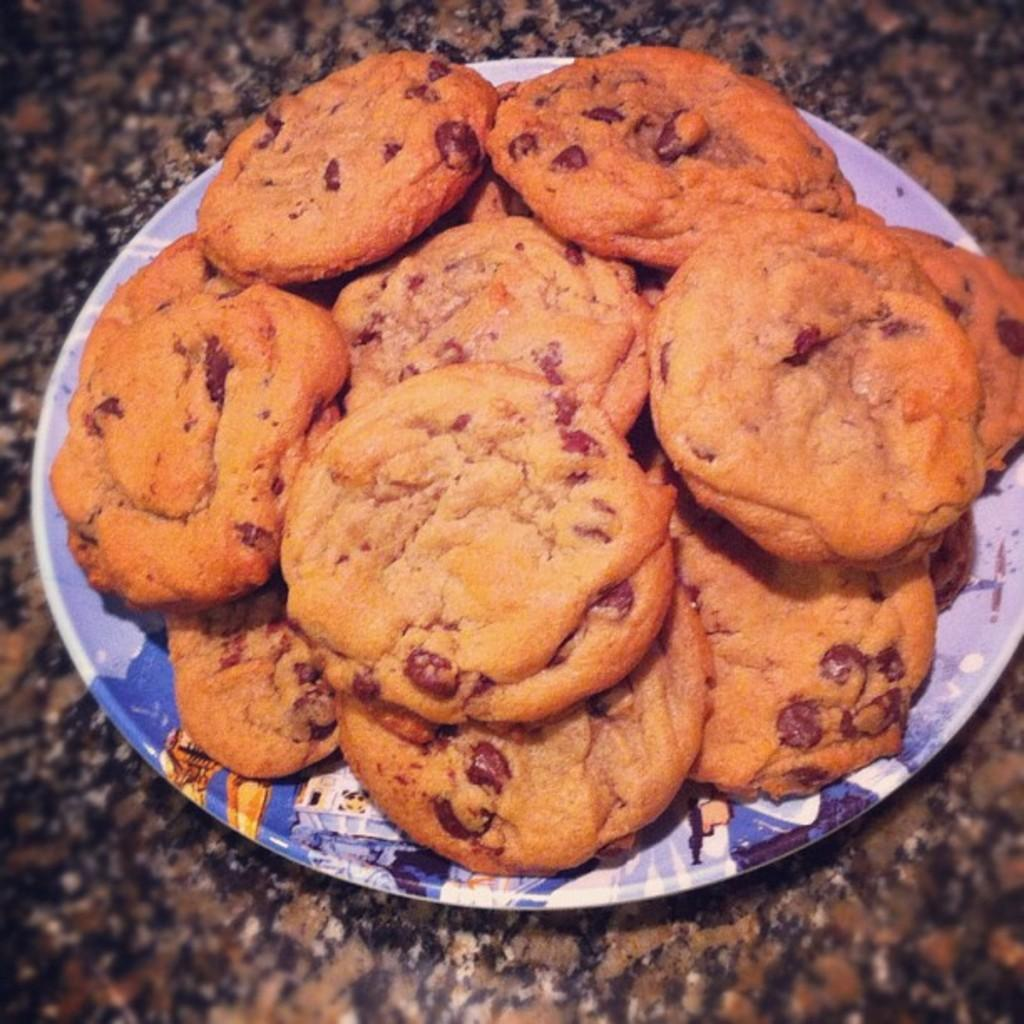What type of food can be seen in the image? There are cookies in the image. How are the cookies arranged in the image? The cookies are in a plate. Where is the plate with cookies located? The plate is on a platform. What type of grain is being taxed in the image? There is no reference to grain or taxation in the image; it features cookies in a plate on a platform. 